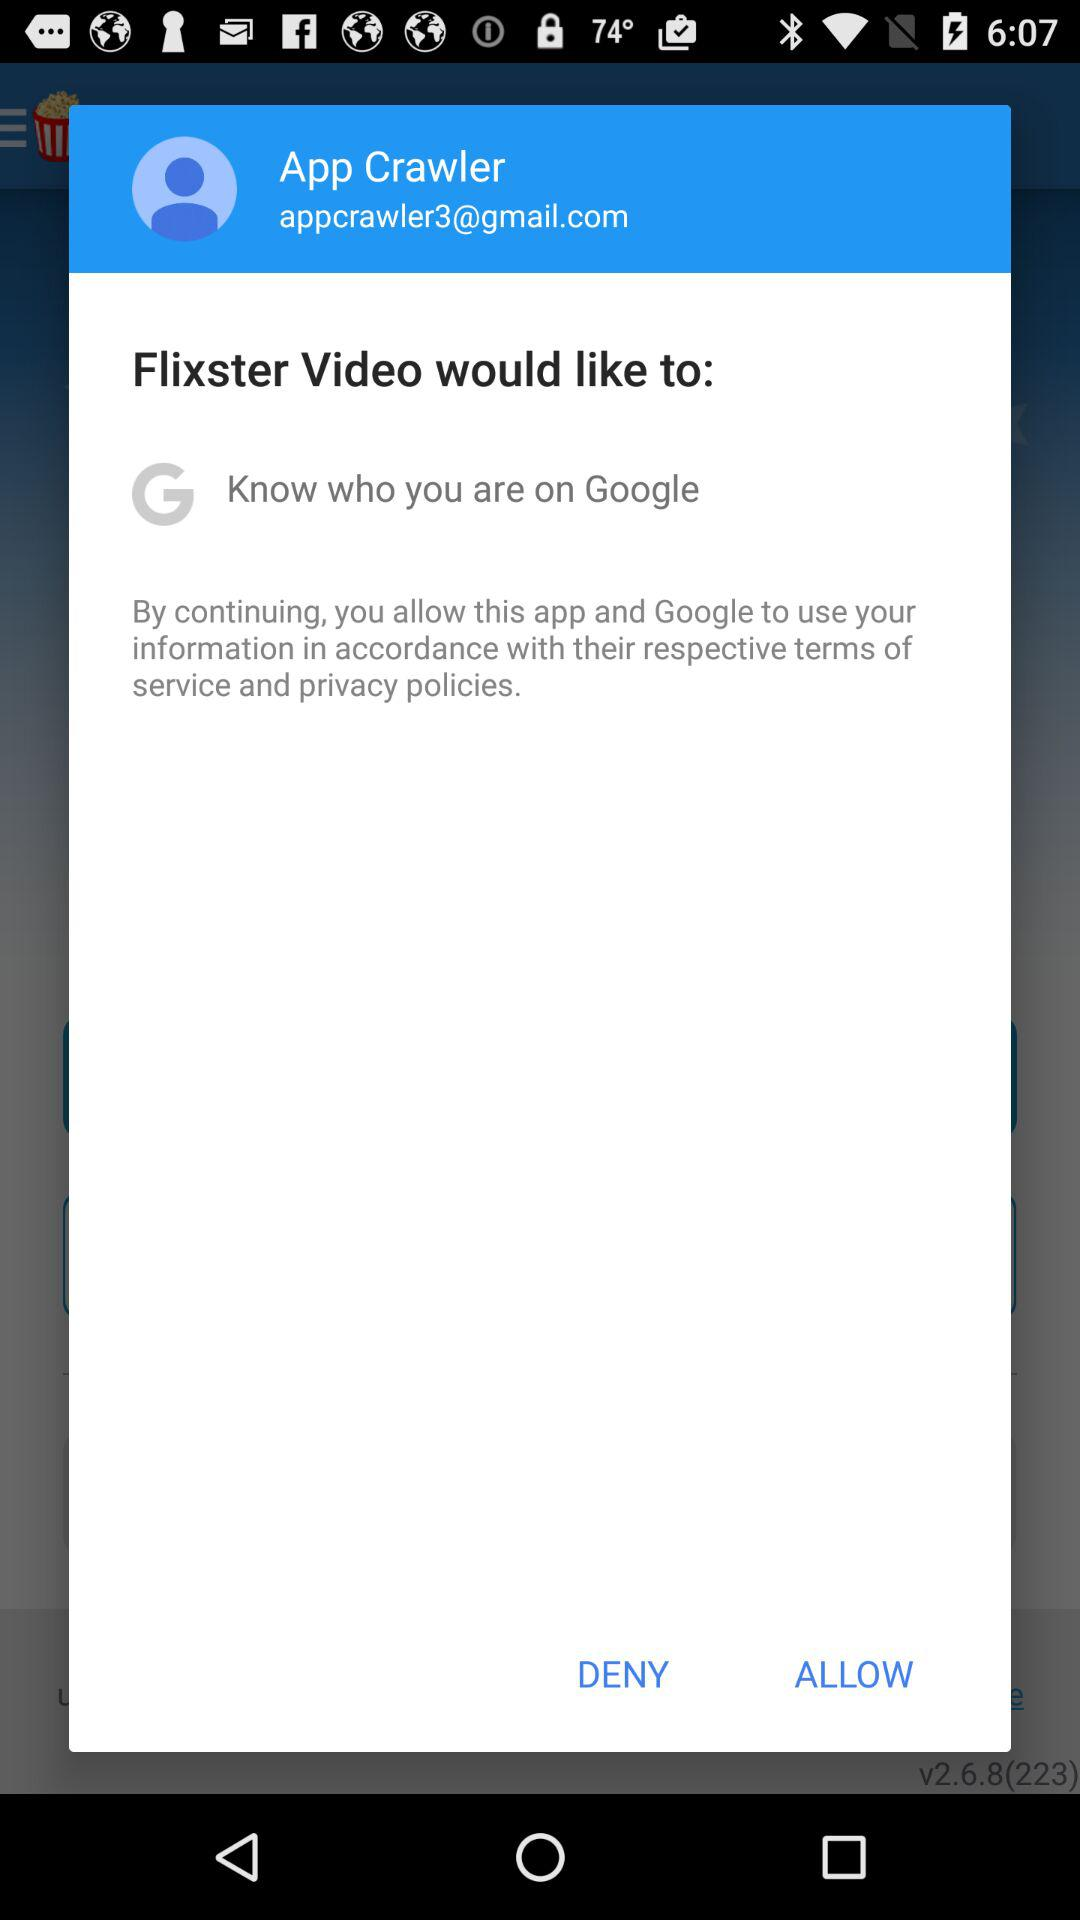What is the email address of the user? The email address is appcrawler3@gmail.com. 